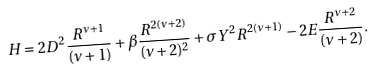Convert formula to latex. <formula><loc_0><loc_0><loc_500><loc_500>H = 2 D ^ { 2 } \frac { R ^ { \nu + 1 } } { ( \nu + 1 ) } + { \beta } \frac { R ^ { 2 ( \nu + 2 ) } } { ( \nu + 2 ) ^ { 2 } } + \sigma Y ^ { 2 } R ^ { 2 ( \nu + 1 ) } - 2 E \frac { R ^ { \nu + 2 } } { ( \nu + 2 ) } .</formula> 